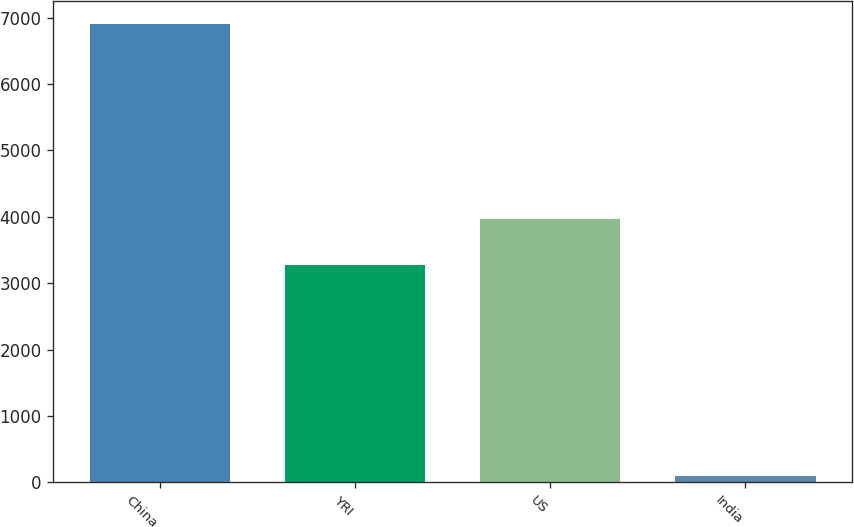Convert chart. <chart><loc_0><loc_0><loc_500><loc_500><bar_chart><fcel>China<fcel>YRI<fcel>US<fcel>India<nl><fcel>6898<fcel>3281<fcel>3960.6<fcel>102<nl></chart> 